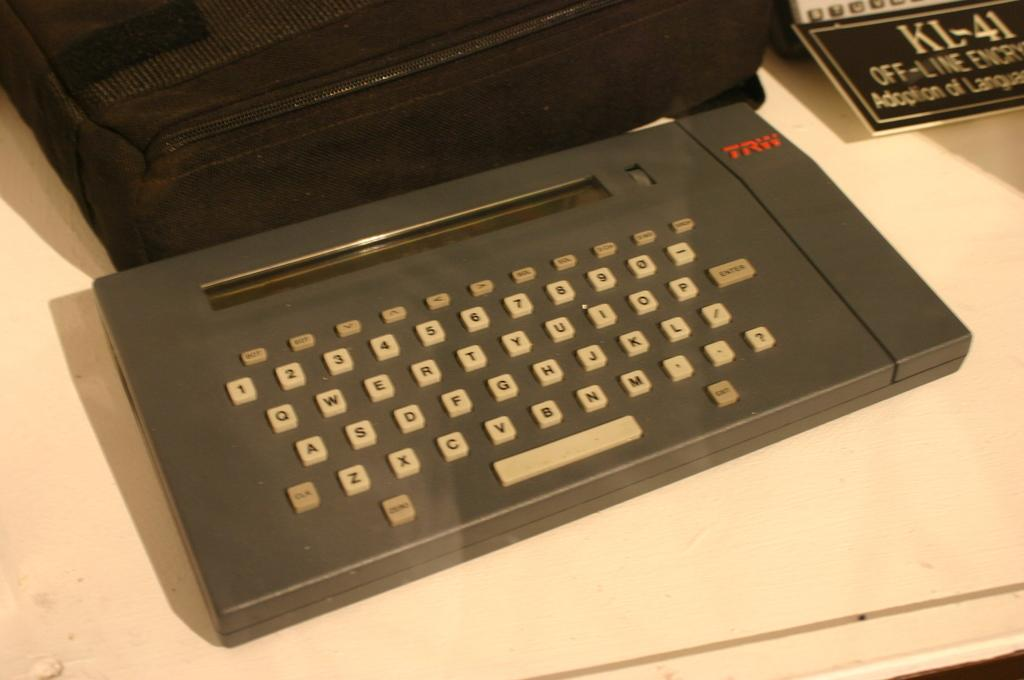<image>
Write a terse but informative summary of the picture. An old TRW keyboard is sitting next to a black bag of some kind. 